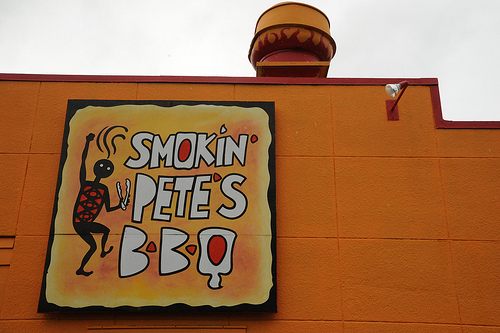<image>
Is there a burger next to the building? No. The burger is not positioned next to the building. They are located in different areas of the scene. 